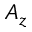<formula> <loc_0><loc_0><loc_500><loc_500>A _ { z }</formula> 